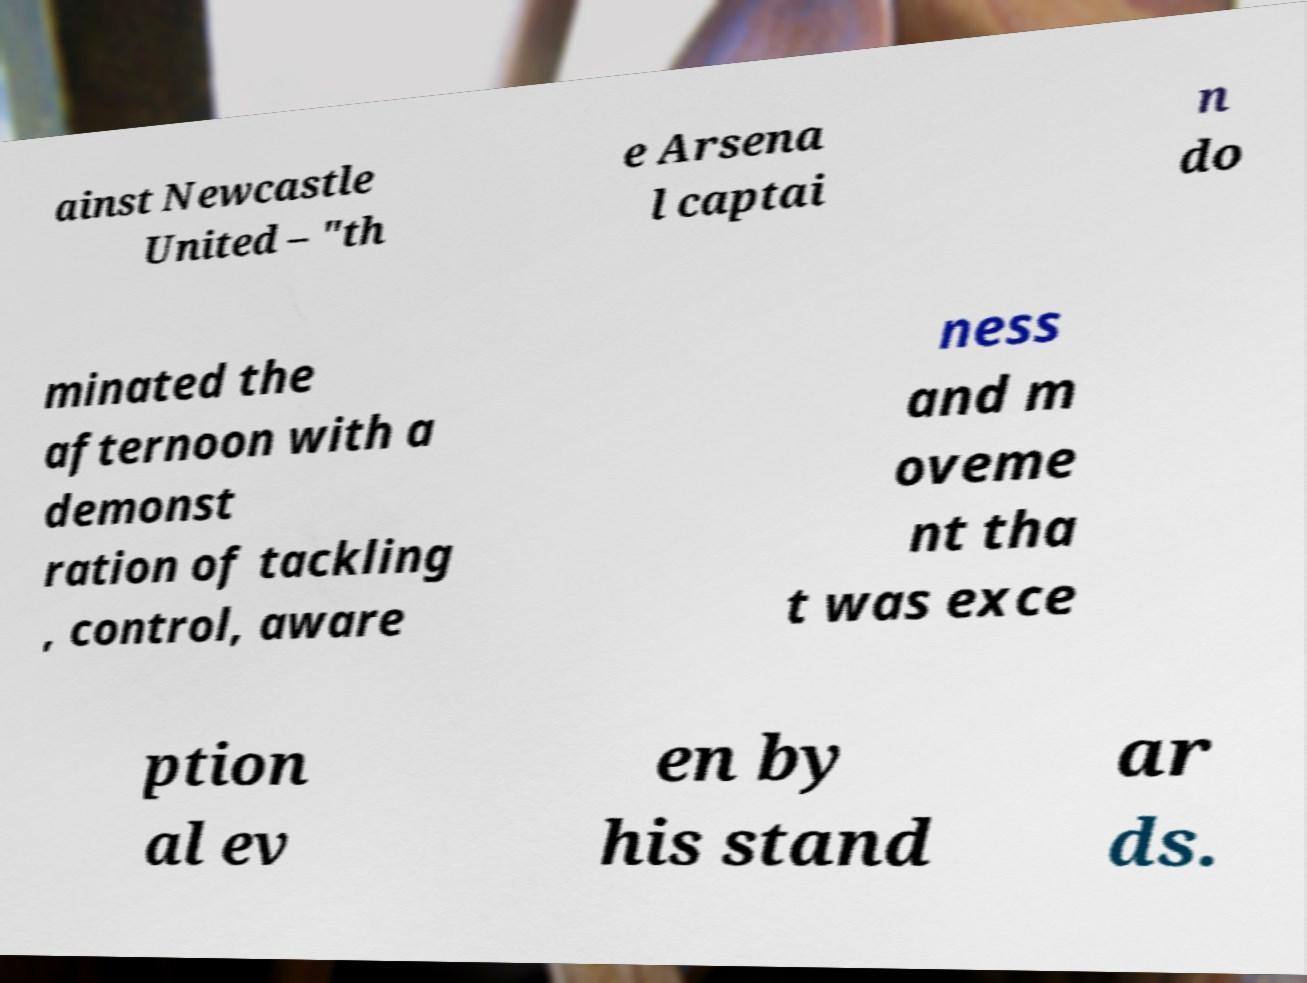I need the written content from this picture converted into text. Can you do that? ainst Newcastle United – "th e Arsena l captai n do minated the afternoon with a demonst ration of tackling , control, aware ness and m oveme nt tha t was exce ption al ev en by his stand ar ds. 